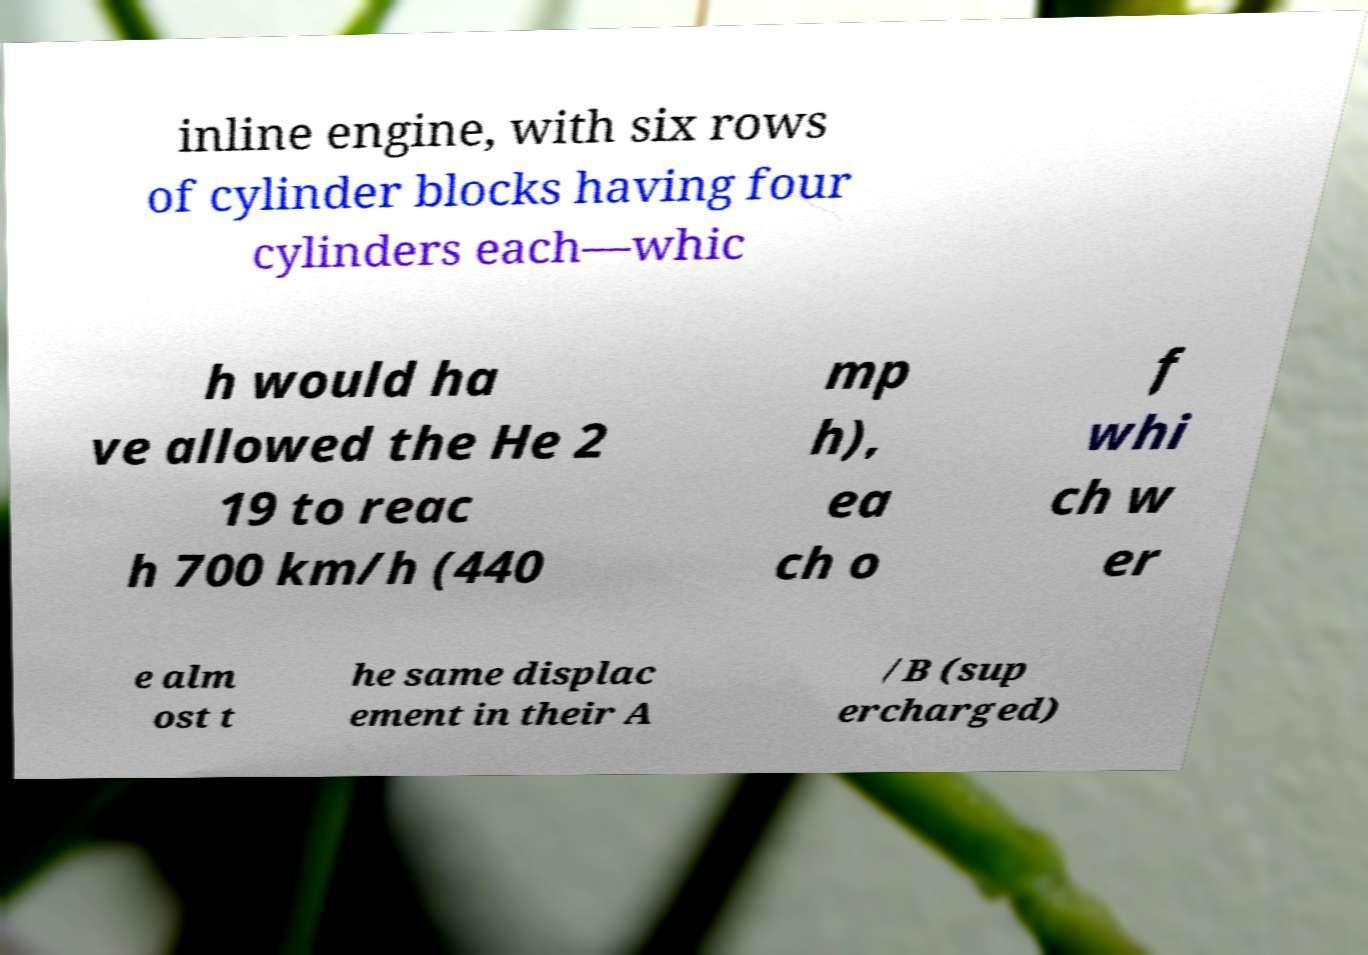Could you assist in decoding the text presented in this image and type it out clearly? inline engine, with six rows of cylinder blocks having four cylinders each—whic h would ha ve allowed the He 2 19 to reac h 700 km/h (440 mp h), ea ch o f whi ch w er e alm ost t he same displac ement in their A /B (sup ercharged) 